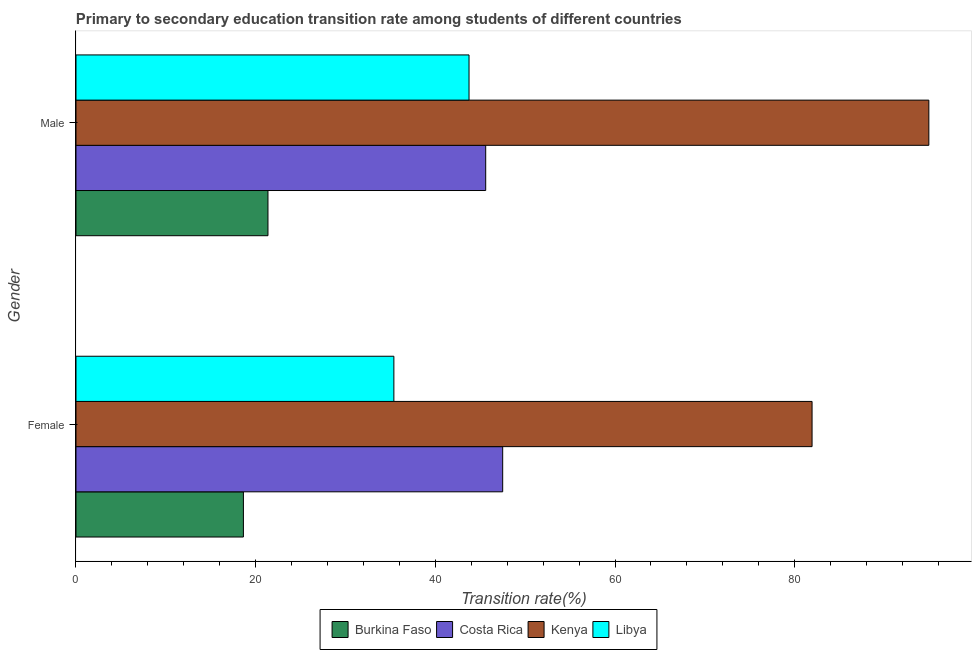Are the number of bars on each tick of the Y-axis equal?
Offer a terse response. Yes. How many bars are there on the 1st tick from the bottom?
Give a very brief answer. 4. What is the transition rate among male students in Burkina Faso?
Your answer should be very brief. 21.37. Across all countries, what is the maximum transition rate among male students?
Make the answer very short. 94.94. Across all countries, what is the minimum transition rate among female students?
Offer a terse response. 18.64. In which country was the transition rate among female students maximum?
Give a very brief answer. Kenya. In which country was the transition rate among male students minimum?
Ensure brevity in your answer.  Burkina Faso. What is the total transition rate among male students in the graph?
Provide a short and direct response. 205.67. What is the difference between the transition rate among male students in Costa Rica and that in Kenya?
Offer a very short reply. -49.33. What is the difference between the transition rate among female students in Kenya and the transition rate among male students in Libya?
Keep it short and to the point. 38.19. What is the average transition rate among female students per country?
Give a very brief answer. 45.86. What is the difference between the transition rate among female students and transition rate among male students in Costa Rica?
Make the answer very short. 1.89. What is the ratio of the transition rate among female students in Costa Rica to that in Libya?
Give a very brief answer. 1.34. Is the transition rate among male students in Kenya less than that in Libya?
Your answer should be compact. No. What does the 2nd bar from the top in Female represents?
Provide a succinct answer. Kenya. How many bars are there?
Your answer should be compact. 8. Are all the bars in the graph horizontal?
Offer a terse response. Yes. How many countries are there in the graph?
Offer a terse response. 4. Does the graph contain any zero values?
Keep it short and to the point. No. How are the legend labels stacked?
Your answer should be very brief. Horizontal. What is the title of the graph?
Offer a terse response. Primary to secondary education transition rate among students of different countries. Does "Uruguay" appear as one of the legend labels in the graph?
Ensure brevity in your answer.  No. What is the label or title of the X-axis?
Provide a short and direct response. Transition rate(%). What is the label or title of the Y-axis?
Make the answer very short. Gender. What is the Transition rate(%) in Burkina Faso in Female?
Offer a very short reply. 18.64. What is the Transition rate(%) of Costa Rica in Female?
Offer a very short reply. 47.5. What is the Transition rate(%) in Kenya in Female?
Offer a terse response. 81.94. What is the Transition rate(%) in Libya in Female?
Provide a short and direct response. 35.38. What is the Transition rate(%) in Burkina Faso in Male?
Keep it short and to the point. 21.37. What is the Transition rate(%) of Costa Rica in Male?
Offer a terse response. 45.61. What is the Transition rate(%) in Kenya in Male?
Keep it short and to the point. 94.94. What is the Transition rate(%) in Libya in Male?
Offer a terse response. 43.75. Across all Gender, what is the maximum Transition rate(%) of Burkina Faso?
Make the answer very short. 21.37. Across all Gender, what is the maximum Transition rate(%) of Costa Rica?
Your answer should be very brief. 47.5. Across all Gender, what is the maximum Transition rate(%) of Kenya?
Your answer should be compact. 94.94. Across all Gender, what is the maximum Transition rate(%) of Libya?
Make the answer very short. 43.75. Across all Gender, what is the minimum Transition rate(%) in Burkina Faso?
Ensure brevity in your answer.  18.64. Across all Gender, what is the minimum Transition rate(%) of Costa Rica?
Keep it short and to the point. 45.61. Across all Gender, what is the minimum Transition rate(%) of Kenya?
Ensure brevity in your answer.  81.94. Across all Gender, what is the minimum Transition rate(%) in Libya?
Offer a terse response. 35.38. What is the total Transition rate(%) in Burkina Faso in the graph?
Your answer should be very brief. 40.01. What is the total Transition rate(%) of Costa Rica in the graph?
Keep it short and to the point. 93.11. What is the total Transition rate(%) of Kenya in the graph?
Your answer should be very brief. 176.87. What is the total Transition rate(%) in Libya in the graph?
Keep it short and to the point. 79.14. What is the difference between the Transition rate(%) in Burkina Faso in Female and that in Male?
Give a very brief answer. -2.73. What is the difference between the Transition rate(%) in Costa Rica in Female and that in Male?
Keep it short and to the point. 1.89. What is the difference between the Transition rate(%) of Kenya in Female and that in Male?
Make the answer very short. -13. What is the difference between the Transition rate(%) in Libya in Female and that in Male?
Give a very brief answer. -8.37. What is the difference between the Transition rate(%) in Burkina Faso in Female and the Transition rate(%) in Costa Rica in Male?
Provide a short and direct response. -26.97. What is the difference between the Transition rate(%) of Burkina Faso in Female and the Transition rate(%) of Kenya in Male?
Give a very brief answer. -76.3. What is the difference between the Transition rate(%) of Burkina Faso in Female and the Transition rate(%) of Libya in Male?
Give a very brief answer. -25.12. What is the difference between the Transition rate(%) of Costa Rica in Female and the Transition rate(%) of Kenya in Male?
Make the answer very short. -47.44. What is the difference between the Transition rate(%) of Costa Rica in Female and the Transition rate(%) of Libya in Male?
Offer a very short reply. 3.75. What is the difference between the Transition rate(%) of Kenya in Female and the Transition rate(%) of Libya in Male?
Keep it short and to the point. 38.19. What is the average Transition rate(%) of Burkina Faso per Gender?
Provide a succinct answer. 20. What is the average Transition rate(%) in Costa Rica per Gender?
Give a very brief answer. 46.55. What is the average Transition rate(%) of Kenya per Gender?
Your answer should be compact. 88.44. What is the average Transition rate(%) in Libya per Gender?
Provide a short and direct response. 39.57. What is the difference between the Transition rate(%) of Burkina Faso and Transition rate(%) of Costa Rica in Female?
Make the answer very short. -28.86. What is the difference between the Transition rate(%) of Burkina Faso and Transition rate(%) of Kenya in Female?
Offer a very short reply. -63.3. What is the difference between the Transition rate(%) in Burkina Faso and Transition rate(%) in Libya in Female?
Offer a very short reply. -16.75. What is the difference between the Transition rate(%) of Costa Rica and Transition rate(%) of Kenya in Female?
Ensure brevity in your answer.  -34.44. What is the difference between the Transition rate(%) of Costa Rica and Transition rate(%) of Libya in Female?
Provide a succinct answer. 12.11. What is the difference between the Transition rate(%) of Kenya and Transition rate(%) of Libya in Female?
Offer a terse response. 46.55. What is the difference between the Transition rate(%) in Burkina Faso and Transition rate(%) in Costa Rica in Male?
Your answer should be compact. -24.24. What is the difference between the Transition rate(%) in Burkina Faso and Transition rate(%) in Kenya in Male?
Your answer should be compact. -73.57. What is the difference between the Transition rate(%) of Burkina Faso and Transition rate(%) of Libya in Male?
Offer a terse response. -22.38. What is the difference between the Transition rate(%) in Costa Rica and Transition rate(%) in Kenya in Male?
Your answer should be very brief. -49.33. What is the difference between the Transition rate(%) of Costa Rica and Transition rate(%) of Libya in Male?
Make the answer very short. 1.86. What is the difference between the Transition rate(%) of Kenya and Transition rate(%) of Libya in Male?
Your response must be concise. 51.18. What is the ratio of the Transition rate(%) in Burkina Faso in Female to that in Male?
Ensure brevity in your answer.  0.87. What is the ratio of the Transition rate(%) of Costa Rica in Female to that in Male?
Offer a terse response. 1.04. What is the ratio of the Transition rate(%) in Kenya in Female to that in Male?
Offer a very short reply. 0.86. What is the ratio of the Transition rate(%) of Libya in Female to that in Male?
Provide a short and direct response. 0.81. What is the difference between the highest and the second highest Transition rate(%) of Burkina Faso?
Your answer should be very brief. 2.73. What is the difference between the highest and the second highest Transition rate(%) of Costa Rica?
Keep it short and to the point. 1.89. What is the difference between the highest and the second highest Transition rate(%) in Kenya?
Your answer should be very brief. 13. What is the difference between the highest and the second highest Transition rate(%) in Libya?
Your answer should be compact. 8.37. What is the difference between the highest and the lowest Transition rate(%) in Burkina Faso?
Your answer should be compact. 2.73. What is the difference between the highest and the lowest Transition rate(%) in Costa Rica?
Offer a very short reply. 1.89. What is the difference between the highest and the lowest Transition rate(%) of Kenya?
Your answer should be very brief. 13. What is the difference between the highest and the lowest Transition rate(%) in Libya?
Provide a short and direct response. 8.37. 